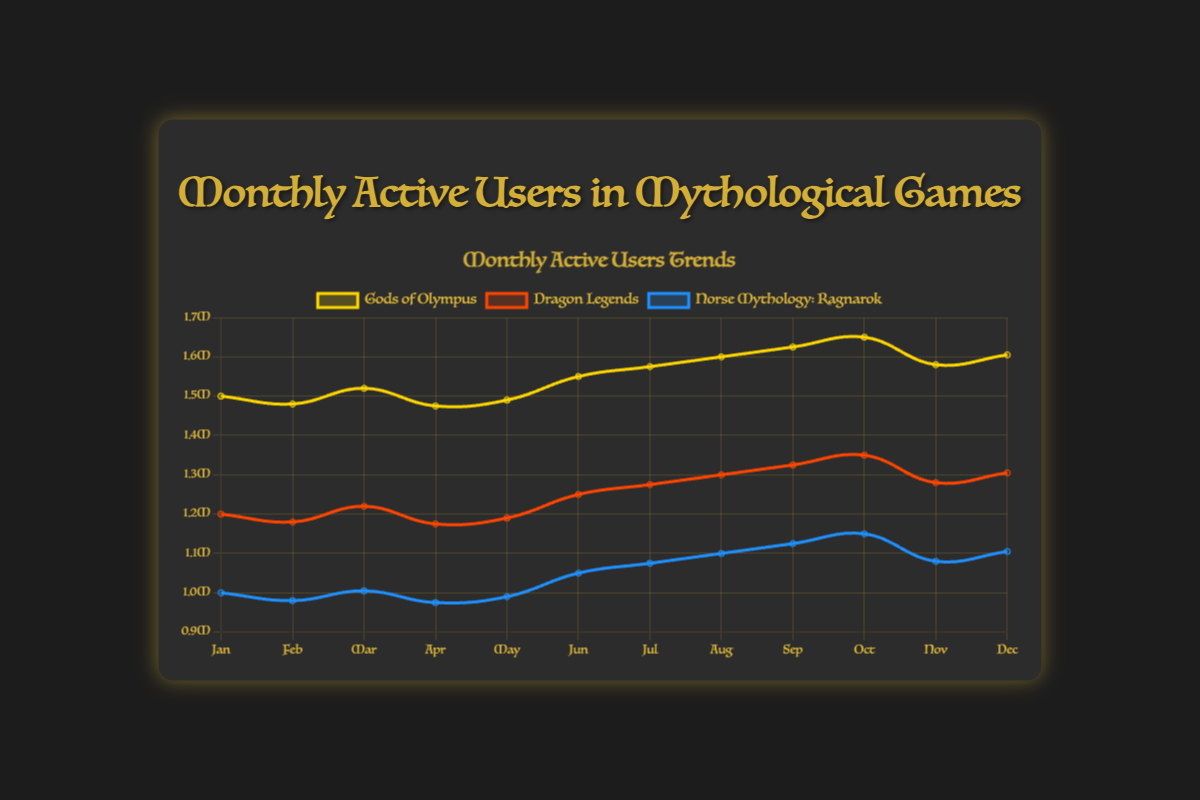Which game has the highest number of active users in October? To find the game with the highest number of active users in October, look at the data points for October in each game's series. "Gods of Olympus" has 1,650,000 active users, "Dragon Legends" has 1,350,000, and "Norse Mythology: Ragnarok" has 1,150,000. "Gods of Olympus" has the highest number.
Answer: Gods of Olympus How many active users did "Dragon Legends" gain from February to September? To calculate the gain in active users from February to September, subtract the number of active users in February from the number in September for "Dragon Legends". Users in February: 1,180,000. Users in September: 1,325,000. The gain is 1,325,000 - 1,180,000 = 145,000.
Answer: 145,000 What is the average number of active users for "Norse Mythology: Ragnarok" from January to December? To find the average, sum up the monthly active users from January to December and divide by 12. Users: 1,000,000 + 980,000 + 1,005,000 + 975,000 + 990,000 + 1,050,000 + 1,075,000 + 1,100,000 + 1,125,000 + 1,150,000 + 1,080,000 + 1,105,000. Total: 12,835,000. Average: 12,835,000 / 12 = 1,069,583.33.
Answer: 1,069,583 Which month saw the lowest number of active users for "Norse Mythology: Ragnarok"? To find the month with the lowest active users for "Norse Mythology: Ragnarok", check the monthly values. February has the lowest with 980,000 users.
Answer: February Between "Gods of Olympus" and "Dragon Legends," which game saw a larger increase in active users from November to December? "Gods of Olympus" had 1,580,000 users in November and 1,605,000 in December, an increase of 25,000. "Dragon Legends" had 1,280,000 in November and 1,305,000 in December, an increase of 25,000. Both games saw an equal increase in active users.
Answer: Equal In which month did "Gods of Olympus" surpass 1.6 million active users for the first time? To find when "Gods of Olympus" surpassed 1.6 million active users for the first time, look for the month where the active users exceeded 1.6 million. This occurred in August with 1,600,000 users.
Answer: August How does the trend from May to August differ between "Gods of Olympus" and "Dragon Legends"? From May to August, "Gods of Olympus" active users increased from 1,490,000 to 1,600,000 (a rise of 110,000). "Dragon Legends" increased from 1,190,000 to 1,300,000 (a rise of 110,000). Both games had a similar rising trend with an equal increase in active users.
Answer: Similar Which game has the most visually distinct color on the plot? The games are differentiated by color; "Gods of Olympus" uses gold, "Dragon Legends" uses orange-red, and "Norse Mythology: Ragnarok" uses blue. Blue generally stands out more against darker backgrounds, making "Norse Mythology: Ragnarok" the most visually distinct.
Answer: Norse Mythology: Ragnarok 